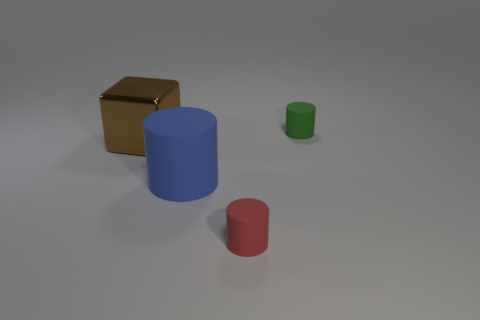Add 3 green things. How many objects exist? 7 Subtract all cylinders. How many objects are left? 1 Add 1 big brown shiny blocks. How many big brown shiny blocks are left? 2 Add 3 small things. How many small things exist? 5 Subtract 0 red blocks. How many objects are left? 4 Subtract all rubber cylinders. Subtract all tiny red rubber things. How many objects are left? 0 